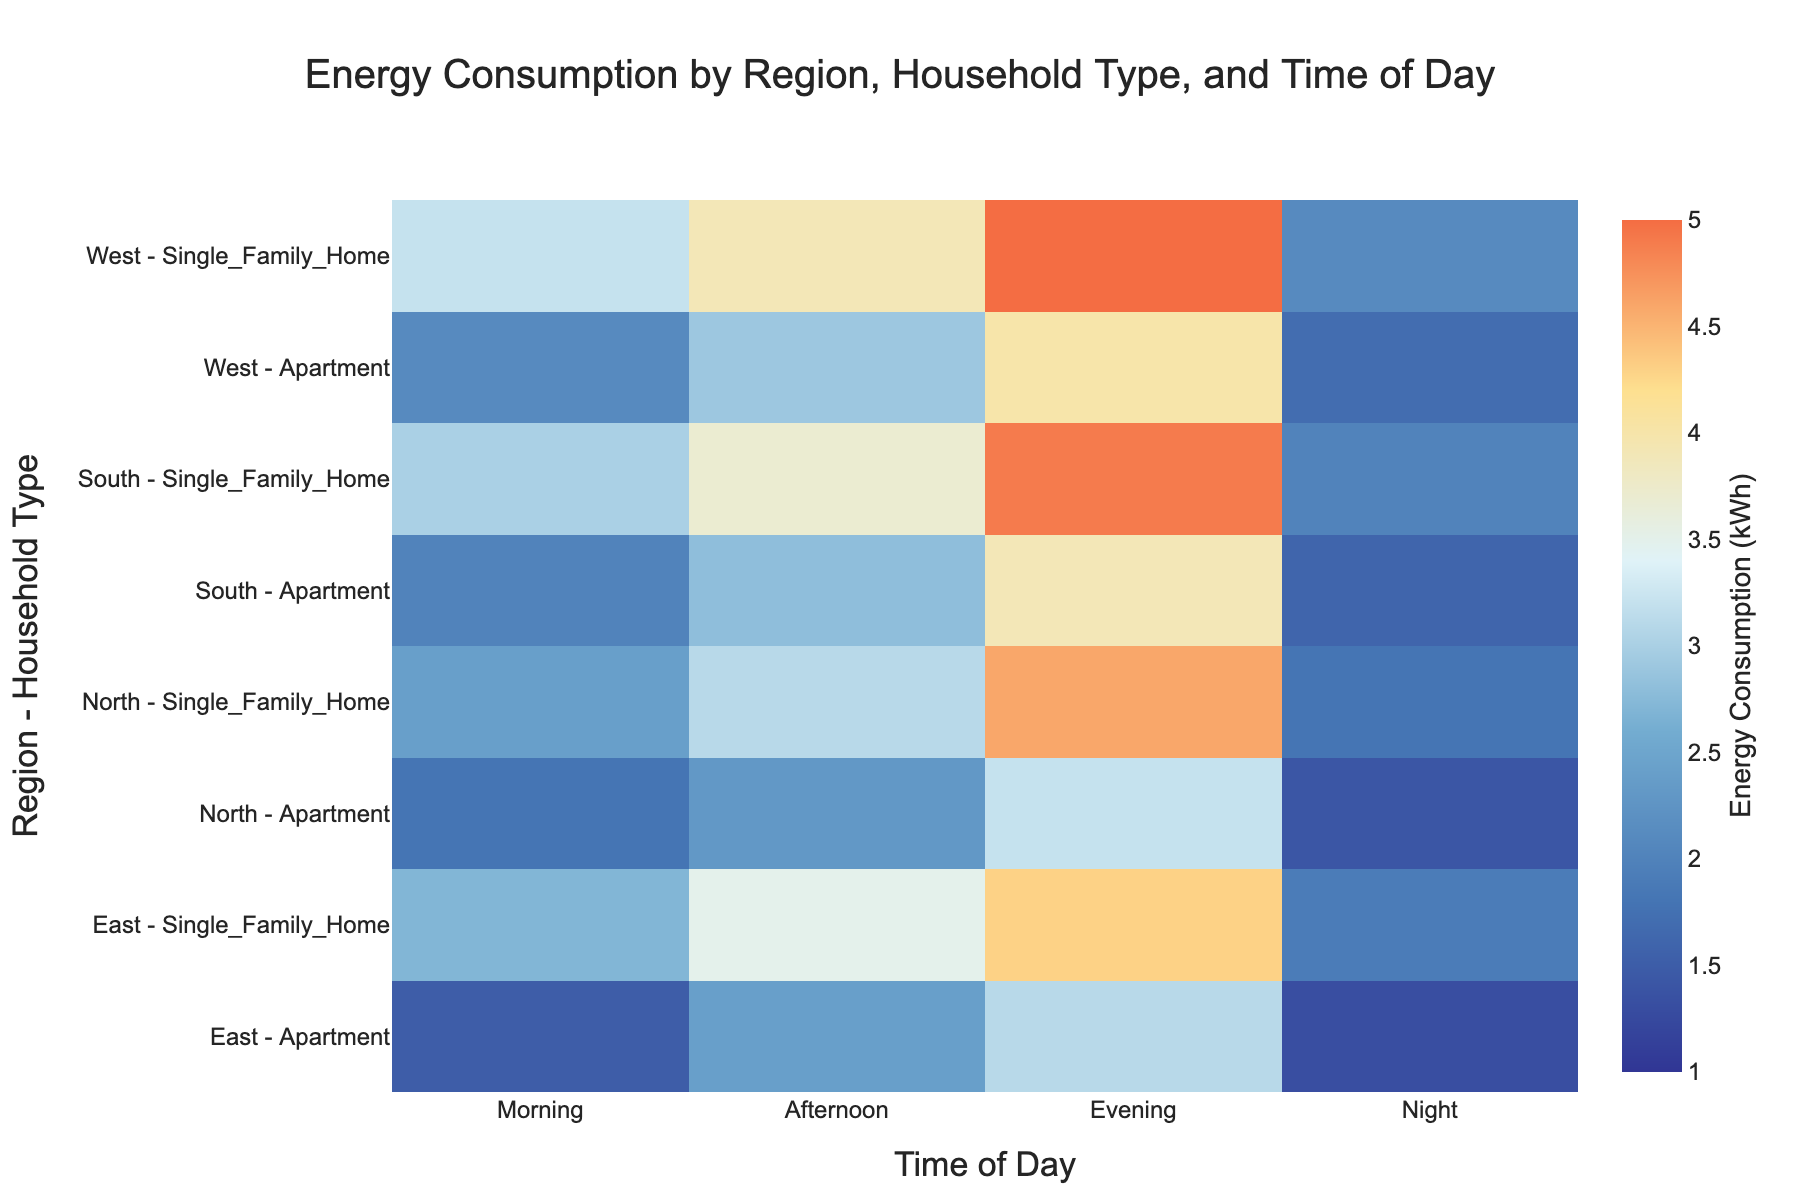What is the title of the heatmap? The title is usually located at the top center of the figure, providing a summary of what the heatmap represents.
Answer: Energy Consumption by Region, Household Type, and Time of Day Which region and household type has the highest energy consumption in the evening? To find the highest consumption in the evening, locate the Evening column and look for the highest value. Then trace this value back to the corresponding row.
Answer: West - Single_Family_Home Which household type and region has the lowest overall energy consumption at night? Scan the Night column for the lowest value and note the corresponding row for the region and household type.
Answer: East - Apartment How does morning energy consumption in Northern Single Family Homes compare to Western Single Family Homes? Look at the rows corresponding to Northern and Western Single Family Homes in the Morning column and compare their values.
Answer: Northern Single Family Homes consume less energy What is the total energy consumption for Southern Apartments across all time periods? Sum the values for Southern Apartments across all columns: Morning, Afternoon, Evening, and Night. Morning (2.0) + Afternoon (2.8) + Evening (3.9) + Night (1.6).
Answer: 10.3 kWh What is the color of the highest energy consumption value and in which region does it occur? Identify the value 5.0 kWh in the heatmap, note its color, and trace it back to its region. The color corresponds to a warm color, as in "rgb(244,109,67)".
Answer: West - Single_Family_Home Compare the average energy consumption in the morning across all regions for Apartments and Single Family Homes. Calculate the average for Apartments and Single Family Homes separately by summing their morning values and dividing by the number of regions (4). (Apartments: 1.8 + 2.0 + 1.5 + 2.1)/4 and (Single Family Homes: 2.4 + 3.0 + 2.7 + 3.2)/4.
Answer: Apartments: 1.85 kWh, Single Family Homes: 2.825 kWh Which regions have a higher energy consumption at night in Single Family Homes compared to Apartments? For each region, compare the values in the Night column for Single Family Homes and Apartments, noting where the former is higher.
Answer: All regions What is the difference in energy consumption between Northern and Southern Single Family Homes in the afternoon? Subtract the afternoon consumption value of Northern Single Family Homes from that of Southern Single Family Homes. 3.7 - 3.1.
Answer: 0.6 kWh What is the overall trend in energy consumption from morning to night across all regions and household types? Observe the change in energy consumption from Morning to Night for each household type and region, noting any increasing or decreasing patterns. Generally, consumption increases from Morning to Evening and then drops at Night.
Answer: Increases to Evening and decreases at Night 